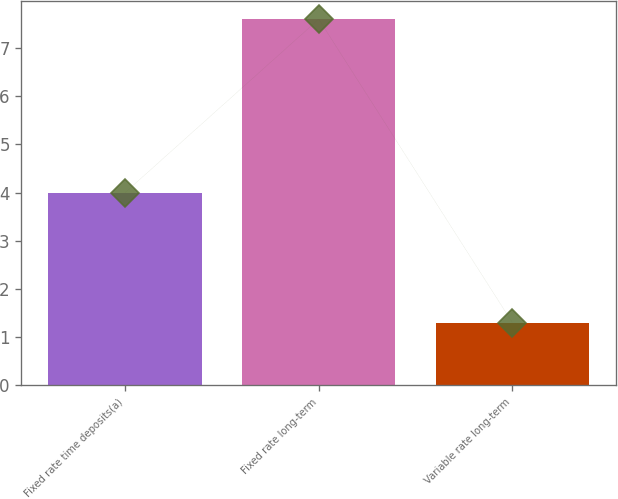<chart> <loc_0><loc_0><loc_500><loc_500><bar_chart><fcel>Fixed rate time deposits(a)<fcel>Fixed rate long-term<fcel>Variable rate long-term<nl><fcel>4<fcel>7.6<fcel>1.3<nl></chart> 